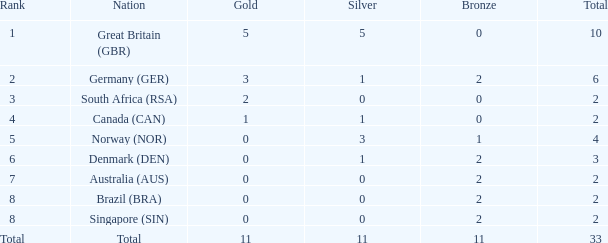What is the total when the nation is brazil (bra) and bronze is more than 2? None. 